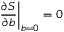Convert formula to latex. <formula><loc_0><loc_0><loc_500><loc_500>\frac { \partial S } { \partial b } \right | _ { b = 0 } = 0</formula> 